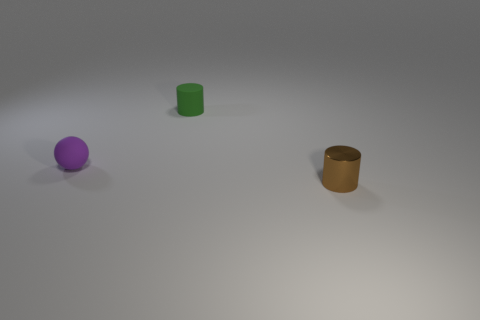How many other things are there of the same material as the green thing?
Make the answer very short. 1. How many objects are green matte cylinders to the right of the rubber sphere or tiny blue cylinders?
Make the answer very short. 1. The object right of the green object has what shape?
Your answer should be very brief. Cylinder. Are there the same number of tiny balls that are on the right side of the brown thing and tiny matte things that are on the right side of the matte sphere?
Offer a very short reply. No. There is a thing that is behind the small brown object and right of the small purple sphere; what color is it?
Ensure brevity in your answer.  Green. What is the material of the tiny cylinder that is right of the cylinder on the left side of the small brown cylinder?
Offer a very short reply. Metal. What number of large objects are brown blocks or brown things?
Offer a terse response. 0. There is a tiny purple sphere; how many green cylinders are in front of it?
Your response must be concise. 0. Is the number of rubber things on the right side of the purple thing greater than the number of yellow matte spheres?
Offer a terse response. Yes. What shape is the small thing that is the same material as the tiny purple ball?
Provide a short and direct response. Cylinder. 